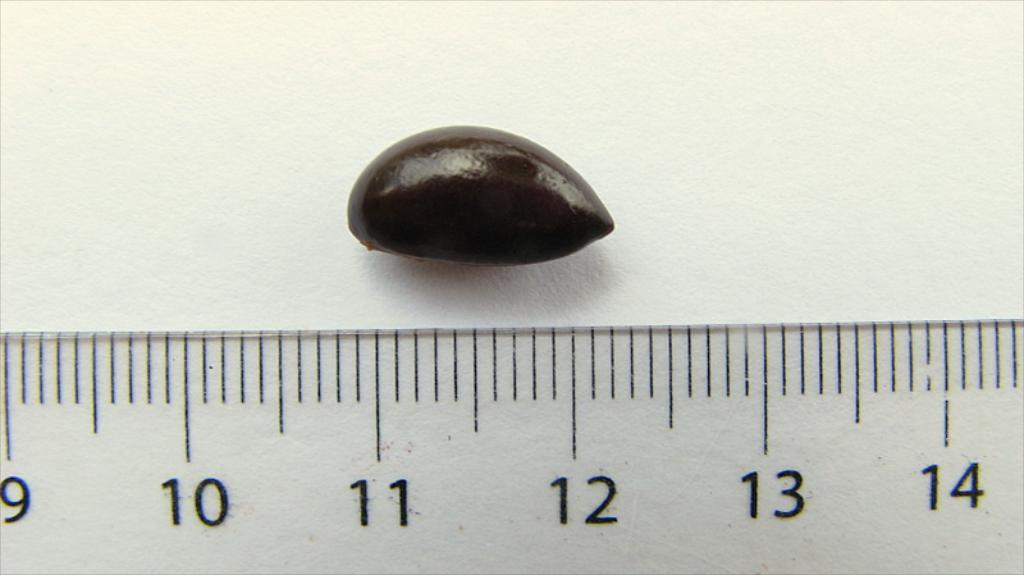<image>
Render a clear and concise summary of the photo. A small chocolate covered item of just over 1 inch in size is being measured by a ruler. 